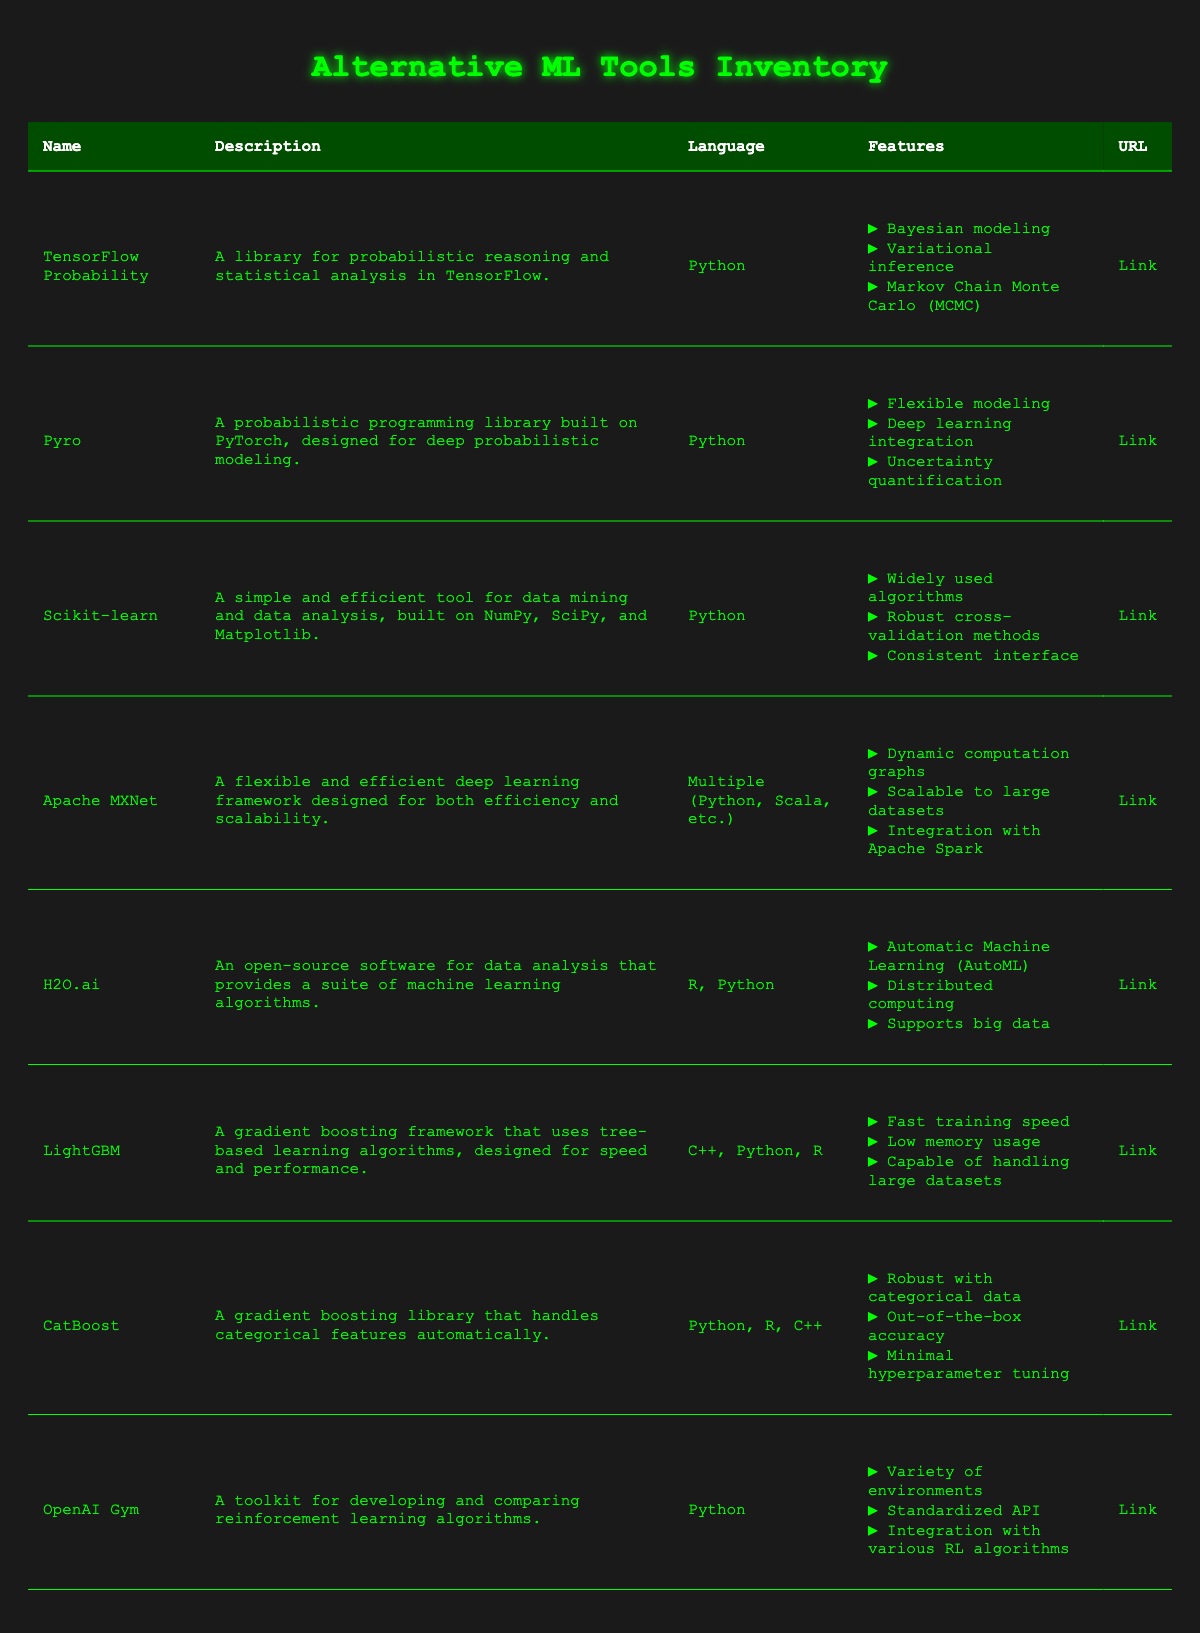What is the language used for TensorFlow Probability? The table shows that TensorFlow Probability is listed under the "language" column, where it indicates "Python."
Answer: Python Which library is designed for deep probabilistic modeling? The table indicates that Pyro is a probabilistic programming library built on PyTorch and is specifically designed for deep probabilistic modeling.
Answer: Pyro How many libraries support the R programming language? By looking through the "language" column in the table, H2O.ai and CatBoost are the libraries that support R, making a total of 2 libraries.
Answer: 2 Is OpenAI Gym a toolkit for developing reinforcement learning algorithms? The table states in the description column for OpenAI Gym that it is indeed a toolkit for developing and comparing reinforcement learning algorithms, confirming the fact.
Answer: Yes Which library has the main feature of AutoML? According to the "features" column in the table, H2O.ai has "Automatic Machine Learning (AutoML)" listed as one of its features, indicating it as the library with that main feature.
Answer: H2O.ai What are the features of LightGBM? To find the required features, we look in the "features" column for LightGBM. It lists "Fast training speed," "Low memory usage," and "Capable of handling large datasets."
Answer: Fast training speed, Low memory usage, Capable of handling large datasets Are there any libraries in the inventory that integrate with Apache Spark? The features for Apache MXNet mention "Integration with Apache Spark," confirming that it indeed integrates with Apache Spark, and no other libraries in the table mention this feature.
Answer: Yes Which library has a feature focusing on uncertainty quantification? Examining the features, Pyro includes "Uncertainty quantification," making it the library that specifically focuses on that feature.
Answer: Pyro What is the difference in the number of programming languages supported by H2O.ai and LightGBM? H2O.ai supports "R, Python," which counts as 2 languages, and LightGBM supports "C++, Python, R," which counts as 3 languages. The difference is 3 - 2 = 1.
Answer: 1 In total, how many features does TensorFlow Probability have? The table shows three features listed under TensorFlow Probability: "Bayesian modeling," "Variational inference," and "Markov Chain Monte Carlo (MCMC)." Thus, it has a total of 3 features.
Answer: 3 